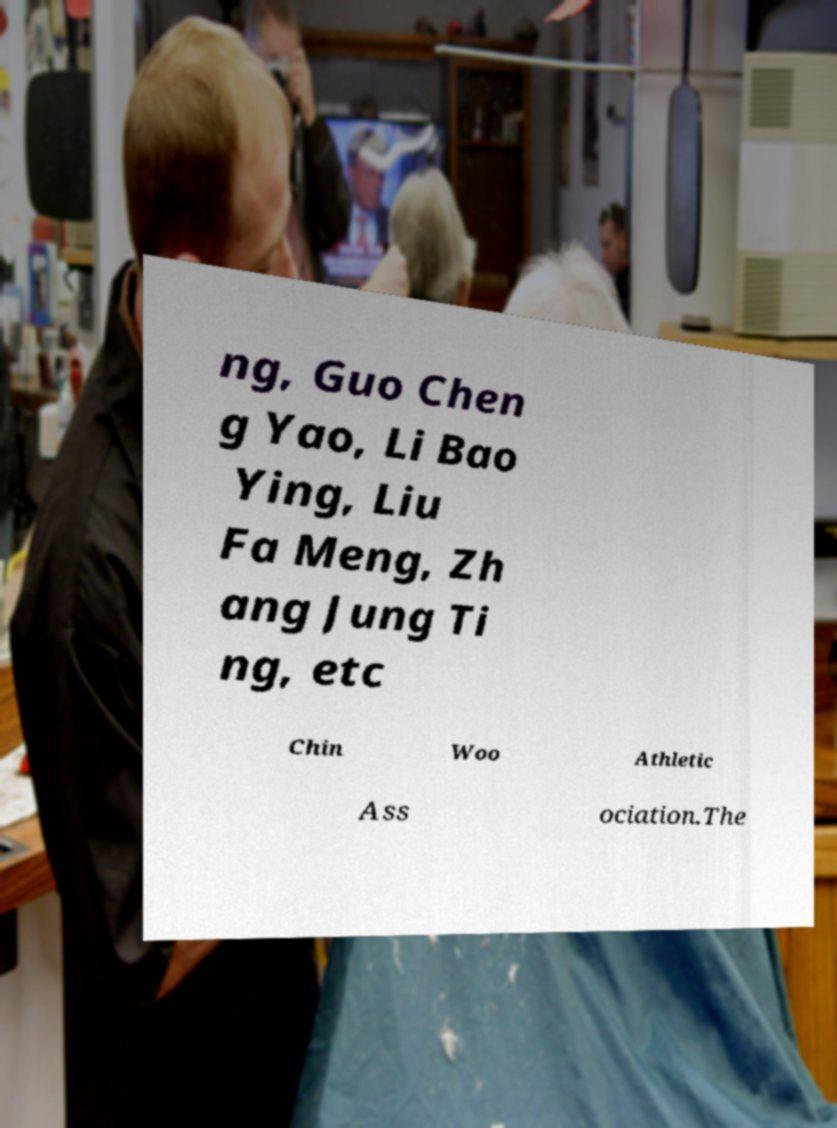What messages or text are displayed in this image? I need them in a readable, typed format. ng, Guo Chen g Yao, Li Bao Ying, Liu Fa Meng, Zh ang Jung Ti ng, etc Chin Woo Athletic Ass ociation.The 